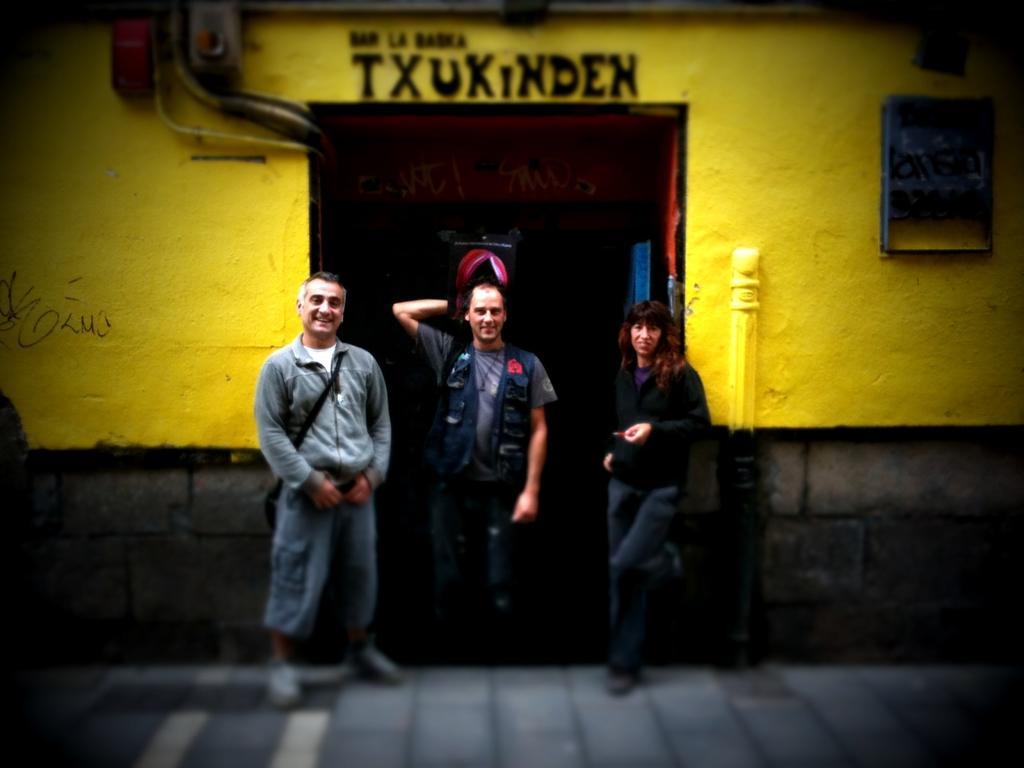In one or two sentences, can you explain what this image depicts? In this image we can see some people standing beside a door. We can also see a frame, pipes and some devices on a wall. We can also see some text. 